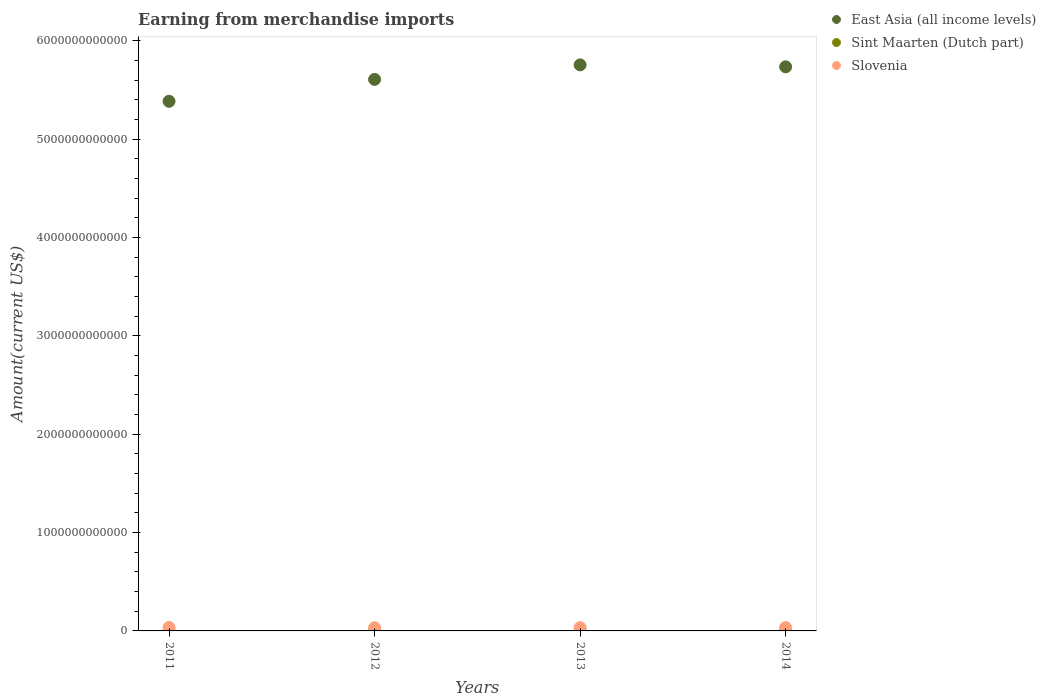What is the amount earned from merchandise imports in Slovenia in 2014?
Offer a very short reply. 3.40e+1. Across all years, what is the maximum amount earned from merchandise imports in Sint Maarten (Dutch part)?
Make the answer very short. 9.50e+08. Across all years, what is the minimum amount earned from merchandise imports in Slovenia?
Your answer should be very brief. 3.20e+1. In which year was the amount earned from merchandise imports in East Asia (all income levels) maximum?
Provide a succinct answer. 2013. In which year was the amount earned from merchandise imports in East Asia (all income levels) minimum?
Make the answer very short. 2011. What is the total amount earned from merchandise imports in Sint Maarten (Dutch part) in the graph?
Keep it short and to the point. 3.38e+09. What is the difference between the amount earned from merchandise imports in East Asia (all income levels) in 2011 and that in 2012?
Your answer should be compact. -2.23e+11. What is the difference between the amount earned from merchandise imports in Sint Maarten (Dutch part) in 2011 and the amount earned from merchandise imports in East Asia (all income levels) in 2012?
Give a very brief answer. -5.61e+12. What is the average amount earned from merchandise imports in Slovenia per year?
Keep it short and to the point. 3.37e+1. In the year 2014, what is the difference between the amount earned from merchandise imports in Slovenia and amount earned from merchandise imports in East Asia (all income levels)?
Ensure brevity in your answer.  -5.70e+12. In how many years, is the amount earned from merchandise imports in East Asia (all income levels) greater than 3000000000000 US$?
Your answer should be compact. 4. What is the ratio of the amount earned from merchandise imports in East Asia (all income levels) in 2011 to that in 2013?
Your answer should be compact. 0.94. Is the amount earned from merchandise imports in East Asia (all income levels) in 2013 less than that in 2014?
Keep it short and to the point. No. What is the difference between the highest and the second highest amount earned from merchandise imports in East Asia (all income levels)?
Your response must be concise. 2.00e+1. What is the difference between the highest and the lowest amount earned from merchandise imports in Sint Maarten (Dutch part)?
Keep it short and to the point. 2.16e+08. In how many years, is the amount earned from merchandise imports in Sint Maarten (Dutch part) greater than the average amount earned from merchandise imports in Sint Maarten (Dutch part) taken over all years?
Offer a very short reply. 2. Is the sum of the amount earned from merchandise imports in Slovenia in 2013 and 2014 greater than the maximum amount earned from merchandise imports in East Asia (all income levels) across all years?
Offer a very short reply. No. Is the amount earned from merchandise imports in Sint Maarten (Dutch part) strictly greater than the amount earned from merchandise imports in East Asia (all income levels) over the years?
Offer a very short reply. No. What is the difference between two consecutive major ticks on the Y-axis?
Offer a terse response. 1.00e+12. Are the values on the major ticks of Y-axis written in scientific E-notation?
Keep it short and to the point. No. Does the graph contain any zero values?
Provide a succinct answer. No. Does the graph contain grids?
Your response must be concise. No. Where does the legend appear in the graph?
Offer a very short reply. Top right. How are the legend labels stacked?
Your answer should be compact. Vertical. What is the title of the graph?
Provide a short and direct response. Earning from merchandise imports. What is the label or title of the Y-axis?
Your answer should be very brief. Amount(current US$). What is the Amount(current US$) of East Asia (all income levels) in 2011?
Your answer should be compact. 5.38e+12. What is the Amount(current US$) in Sint Maarten (Dutch part) in 2011?
Offer a very short reply. 7.34e+08. What is the Amount(current US$) in Slovenia in 2011?
Give a very brief answer. 3.55e+1. What is the Amount(current US$) in East Asia (all income levels) in 2012?
Ensure brevity in your answer.  5.61e+12. What is the Amount(current US$) in Sint Maarten (Dutch part) in 2012?
Make the answer very short. 7.68e+08. What is the Amount(current US$) in Slovenia in 2012?
Offer a terse response. 3.20e+1. What is the Amount(current US$) of East Asia (all income levels) in 2013?
Offer a very short reply. 5.76e+12. What is the Amount(current US$) of Sint Maarten (Dutch part) in 2013?
Offer a terse response. 9.24e+08. What is the Amount(current US$) of Slovenia in 2013?
Provide a short and direct response. 3.34e+1. What is the Amount(current US$) of East Asia (all income levels) in 2014?
Your answer should be very brief. 5.74e+12. What is the Amount(current US$) of Sint Maarten (Dutch part) in 2014?
Your response must be concise. 9.50e+08. What is the Amount(current US$) of Slovenia in 2014?
Ensure brevity in your answer.  3.40e+1. Across all years, what is the maximum Amount(current US$) of East Asia (all income levels)?
Your answer should be very brief. 5.76e+12. Across all years, what is the maximum Amount(current US$) in Sint Maarten (Dutch part)?
Ensure brevity in your answer.  9.50e+08. Across all years, what is the maximum Amount(current US$) in Slovenia?
Your answer should be compact. 3.55e+1. Across all years, what is the minimum Amount(current US$) of East Asia (all income levels)?
Ensure brevity in your answer.  5.38e+12. Across all years, what is the minimum Amount(current US$) in Sint Maarten (Dutch part)?
Ensure brevity in your answer.  7.34e+08. Across all years, what is the minimum Amount(current US$) of Slovenia?
Make the answer very short. 3.20e+1. What is the total Amount(current US$) of East Asia (all income levels) in the graph?
Ensure brevity in your answer.  2.25e+13. What is the total Amount(current US$) in Sint Maarten (Dutch part) in the graph?
Your answer should be compact. 3.38e+09. What is the total Amount(current US$) of Slovenia in the graph?
Keep it short and to the point. 1.35e+11. What is the difference between the Amount(current US$) of East Asia (all income levels) in 2011 and that in 2012?
Ensure brevity in your answer.  -2.23e+11. What is the difference between the Amount(current US$) of Sint Maarten (Dutch part) in 2011 and that in 2012?
Make the answer very short. -3.43e+07. What is the difference between the Amount(current US$) of Slovenia in 2011 and that in 2012?
Provide a short and direct response. 3.49e+09. What is the difference between the Amount(current US$) of East Asia (all income levels) in 2011 and that in 2013?
Your answer should be compact. -3.70e+11. What is the difference between the Amount(current US$) in Sint Maarten (Dutch part) in 2011 and that in 2013?
Provide a short and direct response. -1.91e+08. What is the difference between the Amount(current US$) of Slovenia in 2011 and that in 2013?
Provide a short and direct response. 2.15e+09. What is the difference between the Amount(current US$) of East Asia (all income levels) in 2011 and that in 2014?
Keep it short and to the point. -3.50e+11. What is the difference between the Amount(current US$) of Sint Maarten (Dutch part) in 2011 and that in 2014?
Your answer should be very brief. -2.16e+08. What is the difference between the Amount(current US$) in Slovenia in 2011 and that in 2014?
Provide a succinct answer. 1.49e+09. What is the difference between the Amount(current US$) of East Asia (all income levels) in 2012 and that in 2013?
Give a very brief answer. -1.48e+11. What is the difference between the Amount(current US$) of Sint Maarten (Dutch part) in 2012 and that in 2013?
Offer a terse response. -1.56e+08. What is the difference between the Amount(current US$) of Slovenia in 2012 and that in 2013?
Provide a short and direct response. -1.34e+09. What is the difference between the Amount(current US$) of East Asia (all income levels) in 2012 and that in 2014?
Ensure brevity in your answer.  -1.28e+11. What is the difference between the Amount(current US$) of Sint Maarten (Dutch part) in 2012 and that in 2014?
Your response must be concise. -1.82e+08. What is the difference between the Amount(current US$) in Slovenia in 2012 and that in 2014?
Your answer should be compact. -2.00e+09. What is the difference between the Amount(current US$) of East Asia (all income levels) in 2013 and that in 2014?
Your answer should be very brief. 2.00e+1. What is the difference between the Amount(current US$) in Sint Maarten (Dutch part) in 2013 and that in 2014?
Provide a succinct answer. -2.58e+07. What is the difference between the Amount(current US$) in Slovenia in 2013 and that in 2014?
Make the answer very short. -6.60e+08. What is the difference between the Amount(current US$) of East Asia (all income levels) in 2011 and the Amount(current US$) of Sint Maarten (Dutch part) in 2012?
Your answer should be very brief. 5.38e+12. What is the difference between the Amount(current US$) in East Asia (all income levels) in 2011 and the Amount(current US$) in Slovenia in 2012?
Your answer should be very brief. 5.35e+12. What is the difference between the Amount(current US$) of Sint Maarten (Dutch part) in 2011 and the Amount(current US$) of Slovenia in 2012?
Give a very brief answer. -3.13e+1. What is the difference between the Amount(current US$) in East Asia (all income levels) in 2011 and the Amount(current US$) in Sint Maarten (Dutch part) in 2013?
Ensure brevity in your answer.  5.38e+12. What is the difference between the Amount(current US$) of East Asia (all income levels) in 2011 and the Amount(current US$) of Slovenia in 2013?
Provide a succinct answer. 5.35e+12. What is the difference between the Amount(current US$) of Sint Maarten (Dutch part) in 2011 and the Amount(current US$) of Slovenia in 2013?
Your answer should be compact. -3.26e+1. What is the difference between the Amount(current US$) of East Asia (all income levels) in 2011 and the Amount(current US$) of Sint Maarten (Dutch part) in 2014?
Ensure brevity in your answer.  5.38e+12. What is the difference between the Amount(current US$) in East Asia (all income levels) in 2011 and the Amount(current US$) in Slovenia in 2014?
Give a very brief answer. 5.35e+12. What is the difference between the Amount(current US$) in Sint Maarten (Dutch part) in 2011 and the Amount(current US$) in Slovenia in 2014?
Give a very brief answer. -3.33e+1. What is the difference between the Amount(current US$) in East Asia (all income levels) in 2012 and the Amount(current US$) in Sint Maarten (Dutch part) in 2013?
Your answer should be very brief. 5.61e+12. What is the difference between the Amount(current US$) of East Asia (all income levels) in 2012 and the Amount(current US$) of Slovenia in 2013?
Your answer should be compact. 5.57e+12. What is the difference between the Amount(current US$) of Sint Maarten (Dutch part) in 2012 and the Amount(current US$) of Slovenia in 2013?
Provide a succinct answer. -3.26e+1. What is the difference between the Amount(current US$) in East Asia (all income levels) in 2012 and the Amount(current US$) in Sint Maarten (Dutch part) in 2014?
Provide a succinct answer. 5.61e+12. What is the difference between the Amount(current US$) of East Asia (all income levels) in 2012 and the Amount(current US$) of Slovenia in 2014?
Your answer should be compact. 5.57e+12. What is the difference between the Amount(current US$) in Sint Maarten (Dutch part) in 2012 and the Amount(current US$) in Slovenia in 2014?
Offer a terse response. -3.33e+1. What is the difference between the Amount(current US$) in East Asia (all income levels) in 2013 and the Amount(current US$) in Sint Maarten (Dutch part) in 2014?
Your answer should be compact. 5.75e+12. What is the difference between the Amount(current US$) of East Asia (all income levels) in 2013 and the Amount(current US$) of Slovenia in 2014?
Offer a very short reply. 5.72e+12. What is the difference between the Amount(current US$) of Sint Maarten (Dutch part) in 2013 and the Amount(current US$) of Slovenia in 2014?
Your response must be concise. -3.31e+1. What is the average Amount(current US$) of East Asia (all income levels) per year?
Offer a very short reply. 5.62e+12. What is the average Amount(current US$) in Sint Maarten (Dutch part) per year?
Keep it short and to the point. 8.44e+08. What is the average Amount(current US$) of Slovenia per year?
Ensure brevity in your answer.  3.37e+1. In the year 2011, what is the difference between the Amount(current US$) in East Asia (all income levels) and Amount(current US$) in Sint Maarten (Dutch part)?
Offer a very short reply. 5.38e+12. In the year 2011, what is the difference between the Amount(current US$) of East Asia (all income levels) and Amount(current US$) of Slovenia?
Your answer should be very brief. 5.35e+12. In the year 2011, what is the difference between the Amount(current US$) in Sint Maarten (Dutch part) and Amount(current US$) in Slovenia?
Make the answer very short. -3.48e+1. In the year 2012, what is the difference between the Amount(current US$) in East Asia (all income levels) and Amount(current US$) in Sint Maarten (Dutch part)?
Provide a short and direct response. 5.61e+12. In the year 2012, what is the difference between the Amount(current US$) of East Asia (all income levels) and Amount(current US$) of Slovenia?
Offer a very short reply. 5.58e+12. In the year 2012, what is the difference between the Amount(current US$) of Sint Maarten (Dutch part) and Amount(current US$) of Slovenia?
Provide a short and direct response. -3.13e+1. In the year 2013, what is the difference between the Amount(current US$) in East Asia (all income levels) and Amount(current US$) in Sint Maarten (Dutch part)?
Offer a very short reply. 5.75e+12. In the year 2013, what is the difference between the Amount(current US$) in East Asia (all income levels) and Amount(current US$) in Slovenia?
Give a very brief answer. 5.72e+12. In the year 2013, what is the difference between the Amount(current US$) of Sint Maarten (Dutch part) and Amount(current US$) of Slovenia?
Make the answer very short. -3.24e+1. In the year 2014, what is the difference between the Amount(current US$) of East Asia (all income levels) and Amount(current US$) of Sint Maarten (Dutch part)?
Ensure brevity in your answer.  5.73e+12. In the year 2014, what is the difference between the Amount(current US$) in East Asia (all income levels) and Amount(current US$) in Slovenia?
Offer a very short reply. 5.70e+12. In the year 2014, what is the difference between the Amount(current US$) in Sint Maarten (Dutch part) and Amount(current US$) in Slovenia?
Give a very brief answer. -3.31e+1. What is the ratio of the Amount(current US$) of East Asia (all income levels) in 2011 to that in 2012?
Ensure brevity in your answer.  0.96. What is the ratio of the Amount(current US$) in Sint Maarten (Dutch part) in 2011 to that in 2012?
Keep it short and to the point. 0.96. What is the ratio of the Amount(current US$) in Slovenia in 2011 to that in 2012?
Your answer should be very brief. 1.11. What is the ratio of the Amount(current US$) of East Asia (all income levels) in 2011 to that in 2013?
Keep it short and to the point. 0.94. What is the ratio of the Amount(current US$) of Sint Maarten (Dutch part) in 2011 to that in 2013?
Ensure brevity in your answer.  0.79. What is the ratio of the Amount(current US$) of Slovenia in 2011 to that in 2013?
Your response must be concise. 1.06. What is the ratio of the Amount(current US$) of East Asia (all income levels) in 2011 to that in 2014?
Your answer should be very brief. 0.94. What is the ratio of the Amount(current US$) of Sint Maarten (Dutch part) in 2011 to that in 2014?
Your answer should be very brief. 0.77. What is the ratio of the Amount(current US$) in Slovenia in 2011 to that in 2014?
Make the answer very short. 1.04. What is the ratio of the Amount(current US$) in East Asia (all income levels) in 2012 to that in 2013?
Your answer should be compact. 0.97. What is the ratio of the Amount(current US$) in Sint Maarten (Dutch part) in 2012 to that in 2013?
Keep it short and to the point. 0.83. What is the ratio of the Amount(current US$) in Slovenia in 2012 to that in 2013?
Your response must be concise. 0.96. What is the ratio of the Amount(current US$) in East Asia (all income levels) in 2012 to that in 2014?
Your answer should be compact. 0.98. What is the ratio of the Amount(current US$) in Sint Maarten (Dutch part) in 2012 to that in 2014?
Your answer should be very brief. 0.81. What is the ratio of the Amount(current US$) of Slovenia in 2012 to that in 2014?
Provide a short and direct response. 0.94. What is the ratio of the Amount(current US$) of Sint Maarten (Dutch part) in 2013 to that in 2014?
Your answer should be very brief. 0.97. What is the ratio of the Amount(current US$) in Slovenia in 2013 to that in 2014?
Make the answer very short. 0.98. What is the difference between the highest and the second highest Amount(current US$) in East Asia (all income levels)?
Offer a very short reply. 2.00e+1. What is the difference between the highest and the second highest Amount(current US$) of Sint Maarten (Dutch part)?
Your answer should be compact. 2.58e+07. What is the difference between the highest and the second highest Amount(current US$) in Slovenia?
Offer a very short reply. 1.49e+09. What is the difference between the highest and the lowest Amount(current US$) in East Asia (all income levels)?
Keep it short and to the point. 3.70e+11. What is the difference between the highest and the lowest Amount(current US$) in Sint Maarten (Dutch part)?
Ensure brevity in your answer.  2.16e+08. What is the difference between the highest and the lowest Amount(current US$) in Slovenia?
Keep it short and to the point. 3.49e+09. 